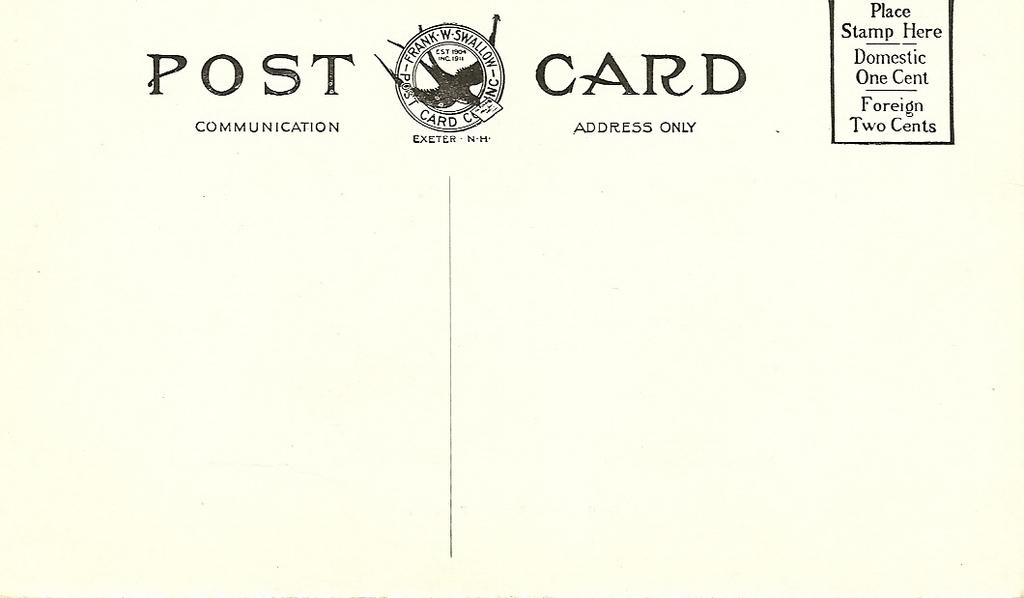<image>
Describe the image concisely. Post card that is empty and needs a stamp to place on the right side 